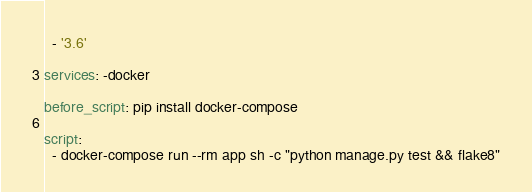Convert code to text. <code><loc_0><loc_0><loc_500><loc_500><_YAML_>  - '3.6'

services: -docker

before_script: pip install docker-compose

script:
  - docker-compose run --rm app sh -c "python manage.py test && flake8"
</code> 